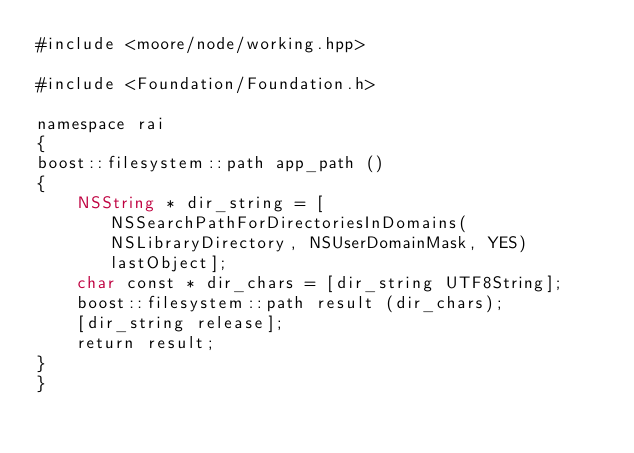<code> <loc_0><loc_0><loc_500><loc_500><_ObjectiveC_>#include <moore/node/working.hpp>

#include <Foundation/Foundation.h>

namespace rai
{
boost::filesystem::path app_path ()
{
	NSString * dir_string = [NSSearchPathForDirectoriesInDomains(NSLibraryDirectory, NSUserDomainMask, YES) lastObject];
	char const * dir_chars = [dir_string UTF8String];
	boost::filesystem::path result (dir_chars);
	[dir_string release];
	return result;
}
}</code> 